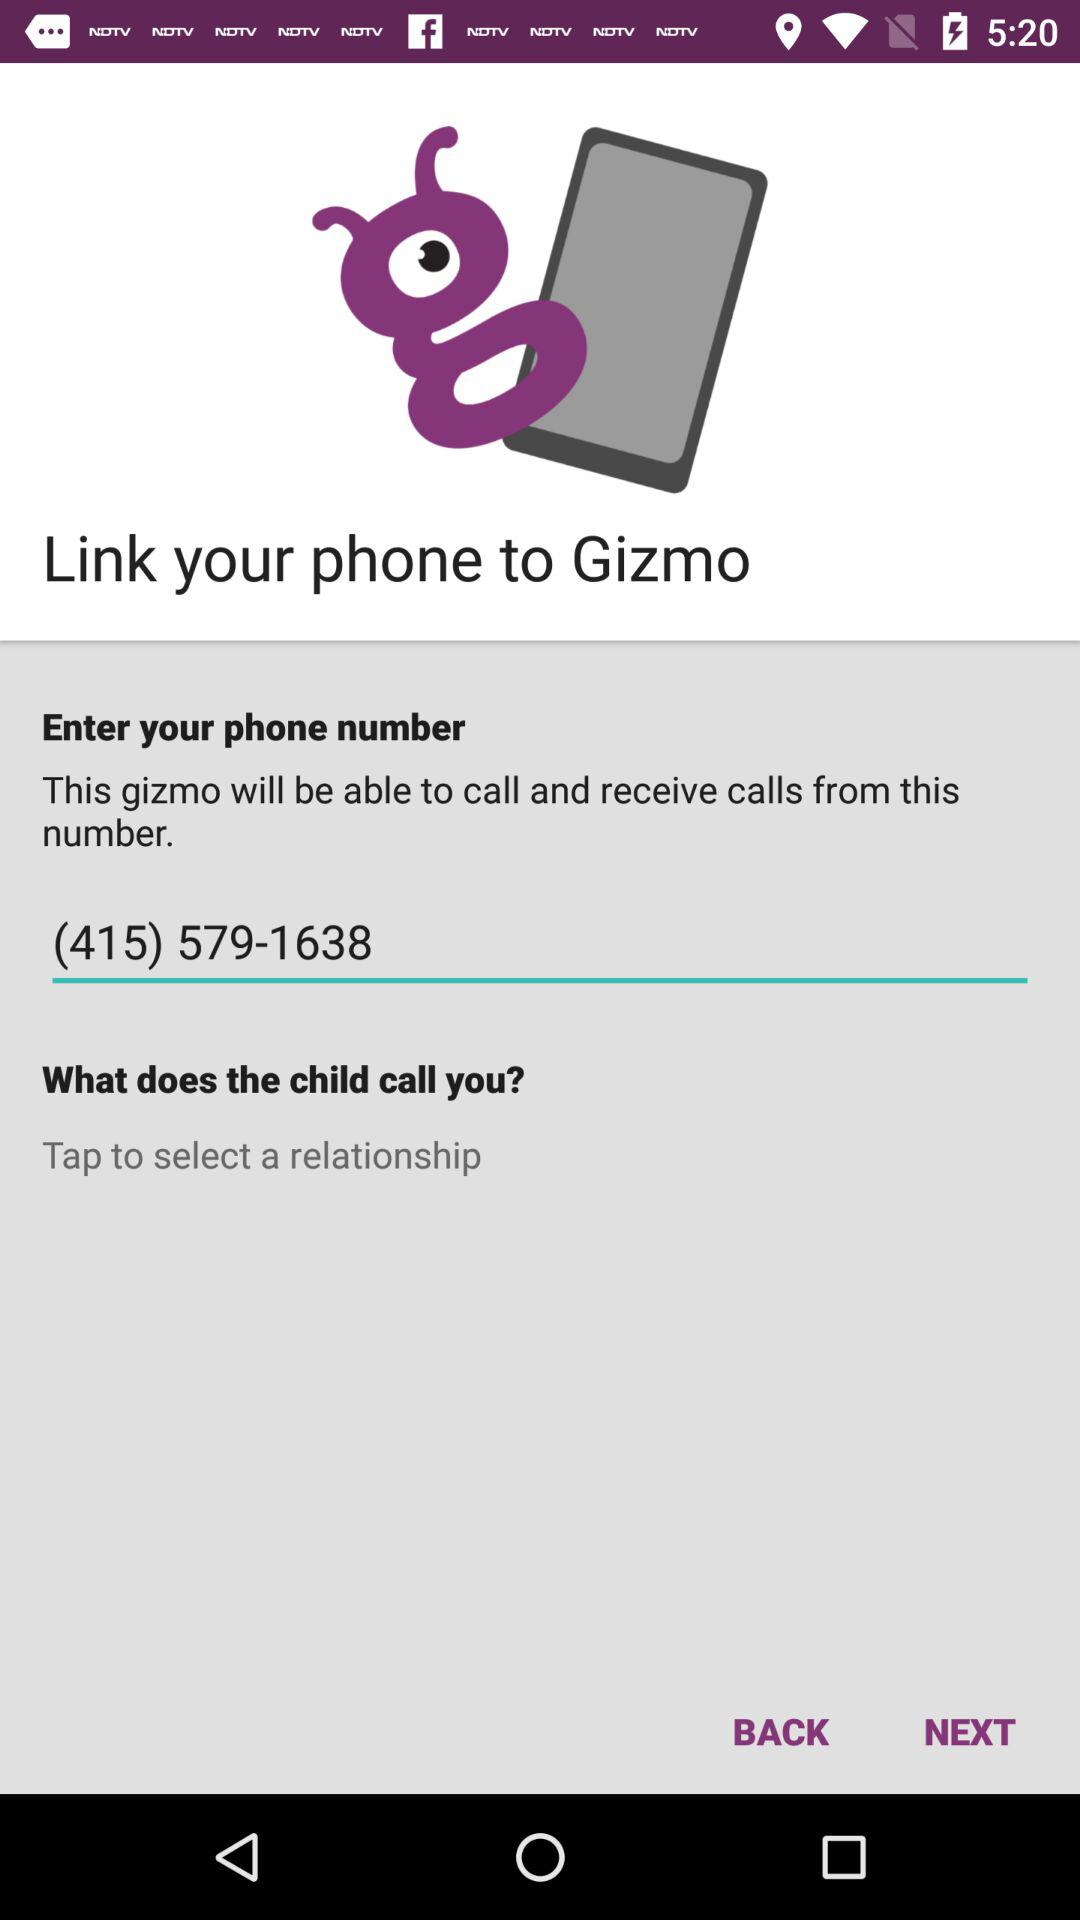What is the app name? The app name is "Gizmo". 